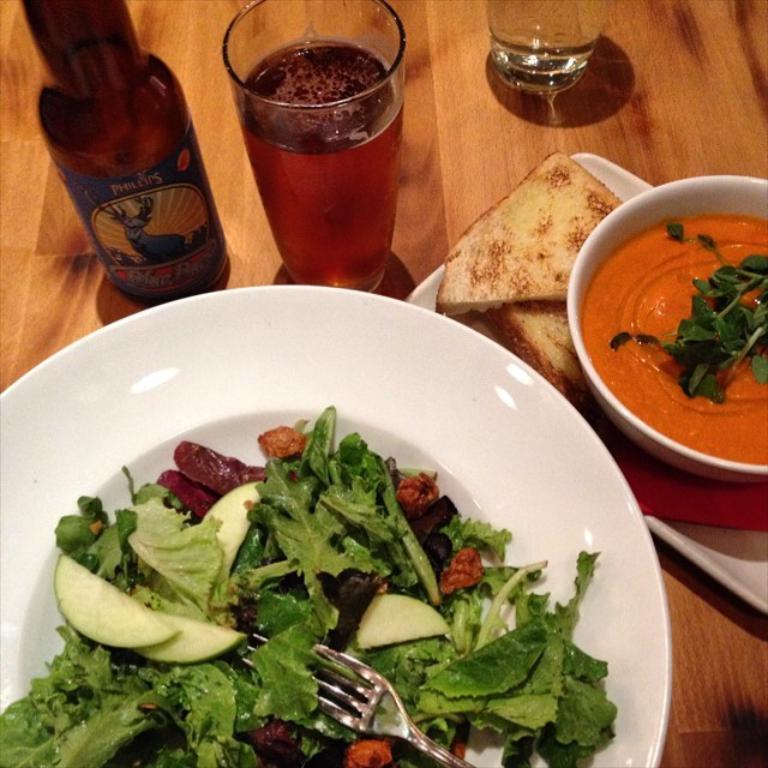How would you summarize this image in a sentence or two? On a wooden table there is a white plate which contains salad and a fork. There are breads and other food items in a bowl. There are glasses and a glass bottle. 